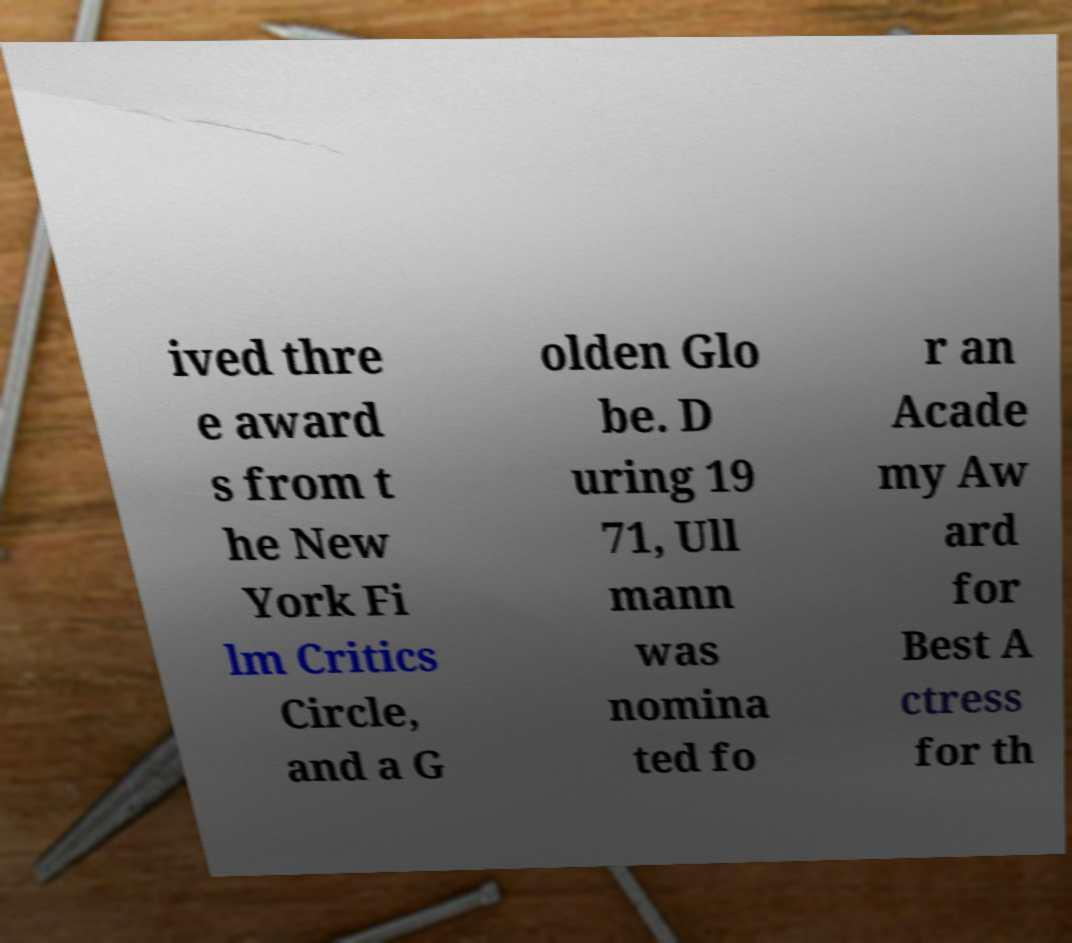Could you assist in decoding the text presented in this image and type it out clearly? ived thre e award s from t he New York Fi lm Critics Circle, and a G olden Glo be. D uring 19 71, Ull mann was nomina ted fo r an Acade my Aw ard for Best A ctress for th 